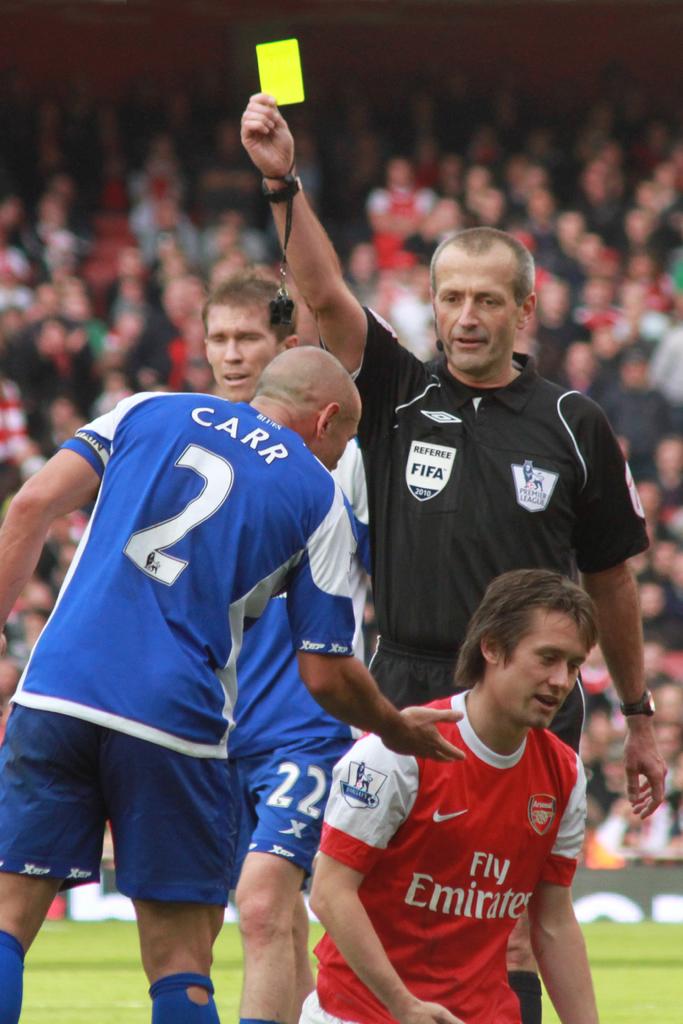What number is carr?
Offer a very short reply. 2. 